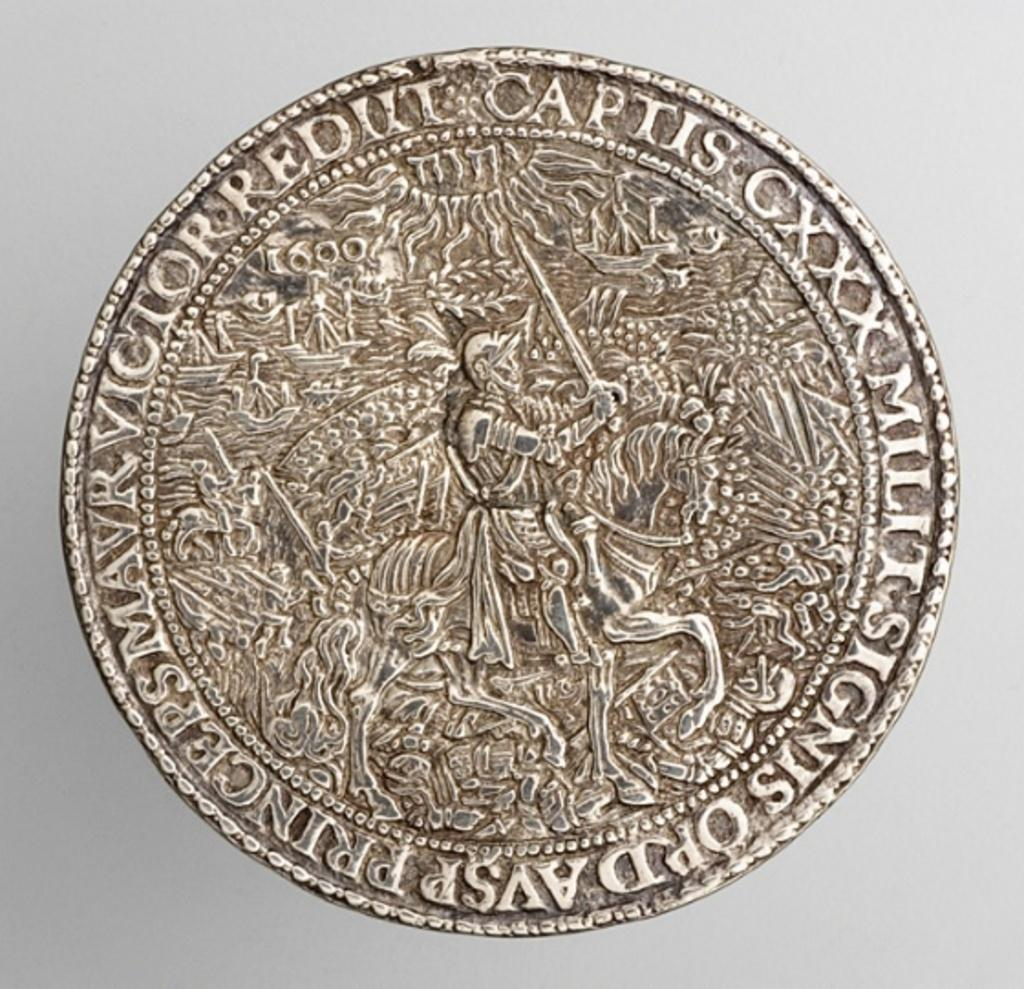What is the main subject of the image? The main subject of the image is a warrior on a horse. How is the warrior and horse depicted in the image? The warrior and horse are engraved on a coin. What type of wire is used to control the horse's movements in the image? There is no wire present in the image, as the warrior and horse are engraved on a coin. How far away is the warrior from the horse in the image? The warrior and horse are depicted as a single entity in the image, so there is no distance between them. 